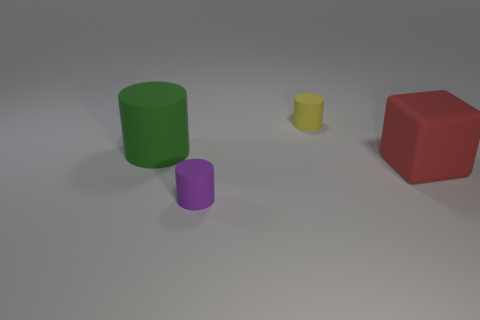The rubber object to the right of the small yellow rubber cylinder has what shape?
Keep it short and to the point. Cube. How many things are big red rubber cylinders or objects that are behind the big red object?
Offer a terse response. 2. Is the material of the big green object the same as the big red block?
Provide a succinct answer. Yes. Is the number of large objects behind the large green matte object the same as the number of large cylinders in front of the small purple rubber thing?
Your answer should be very brief. Yes. There is a small purple rubber thing; how many tiny rubber cylinders are behind it?
Your answer should be very brief. 1. How many things are either purple cylinders or large green things?
Your response must be concise. 2. What number of red rubber cubes have the same size as the yellow rubber object?
Keep it short and to the point. 0. What is the shape of the large thing that is in front of the large rubber object that is to the left of the yellow matte thing?
Ensure brevity in your answer.  Cube. Are there fewer purple rubber cylinders than big yellow objects?
Provide a succinct answer. No. The cylinder behind the green rubber cylinder is what color?
Ensure brevity in your answer.  Yellow. 